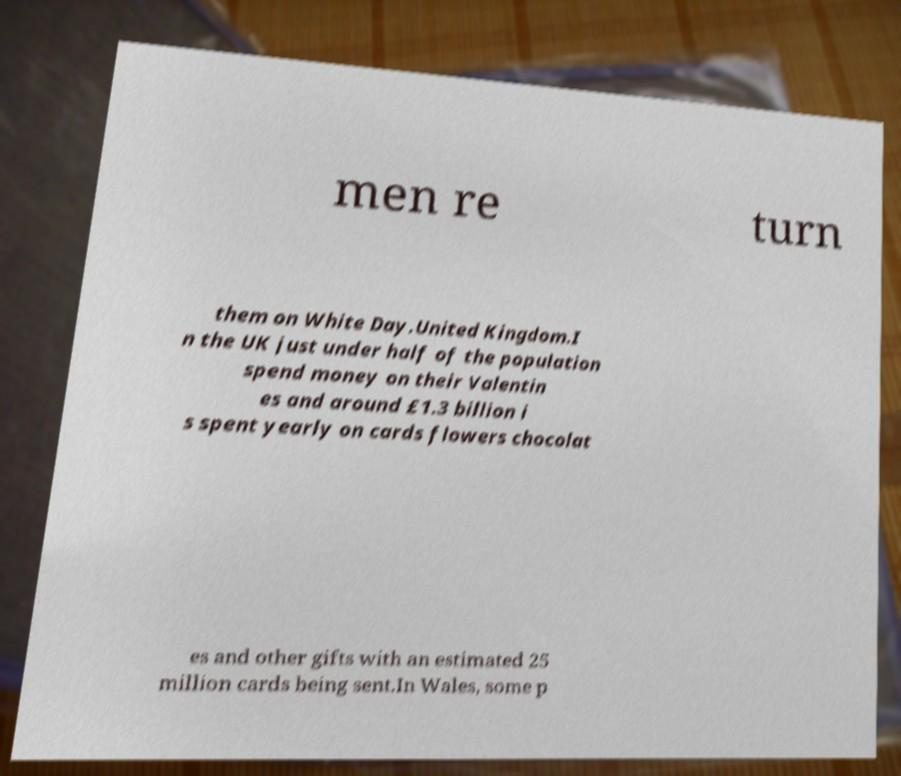Can you read and provide the text displayed in the image?This photo seems to have some interesting text. Can you extract and type it out for me? men re turn them on White Day.United Kingdom.I n the UK just under half of the population spend money on their Valentin es and around £1.3 billion i s spent yearly on cards flowers chocolat es and other gifts with an estimated 25 million cards being sent.In Wales, some p 